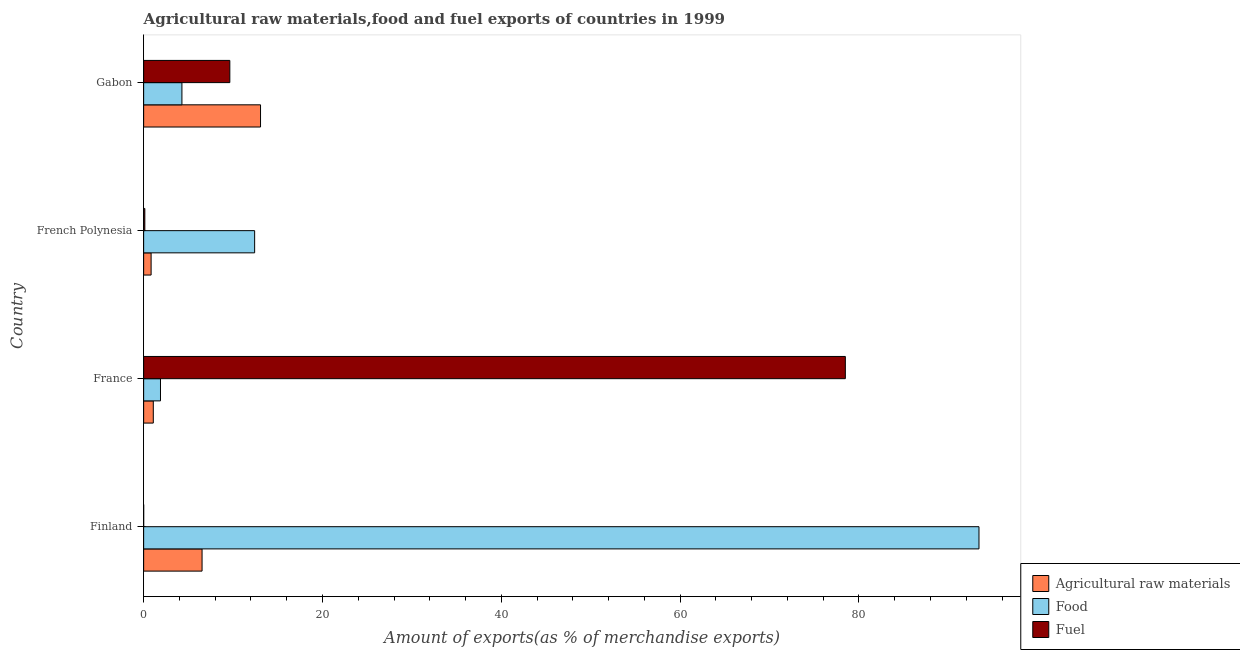How many groups of bars are there?
Offer a very short reply. 4. Are the number of bars on each tick of the Y-axis equal?
Keep it short and to the point. Yes. How many bars are there on the 1st tick from the bottom?
Your response must be concise. 3. What is the label of the 1st group of bars from the top?
Your response must be concise. Gabon. What is the percentage of fuel exports in French Polynesia?
Your answer should be very brief. 0.13. Across all countries, what is the maximum percentage of raw materials exports?
Make the answer very short. 13.07. Across all countries, what is the minimum percentage of raw materials exports?
Ensure brevity in your answer.  0.83. What is the total percentage of food exports in the graph?
Your answer should be very brief. 112. What is the difference between the percentage of raw materials exports in Finland and that in French Polynesia?
Give a very brief answer. 5.7. What is the difference between the percentage of raw materials exports in Finland and the percentage of food exports in Gabon?
Provide a short and direct response. 2.25. What is the average percentage of fuel exports per country?
Your response must be concise. 22.06. What is the difference between the percentage of raw materials exports and percentage of food exports in Finland?
Your answer should be compact. -86.89. What is the ratio of the percentage of raw materials exports in Finland to that in French Polynesia?
Provide a short and direct response. 7.83. What is the difference between the highest and the second highest percentage of raw materials exports?
Give a very brief answer. 6.54. What is the difference between the highest and the lowest percentage of fuel exports?
Provide a short and direct response. 78.47. In how many countries, is the percentage of fuel exports greater than the average percentage of fuel exports taken over all countries?
Ensure brevity in your answer.  1. Is the sum of the percentage of raw materials exports in France and Gabon greater than the maximum percentage of fuel exports across all countries?
Your answer should be very brief. No. What does the 3rd bar from the top in France represents?
Offer a very short reply. Agricultural raw materials. What does the 1st bar from the bottom in Finland represents?
Give a very brief answer. Agricultural raw materials. Is it the case that in every country, the sum of the percentage of raw materials exports and percentage of food exports is greater than the percentage of fuel exports?
Make the answer very short. No. How many bars are there?
Ensure brevity in your answer.  12. What is the difference between two consecutive major ticks on the X-axis?
Your response must be concise. 20. Does the graph contain grids?
Offer a terse response. No. Where does the legend appear in the graph?
Offer a very short reply. Bottom right. How are the legend labels stacked?
Provide a short and direct response. Vertical. What is the title of the graph?
Keep it short and to the point. Agricultural raw materials,food and fuel exports of countries in 1999. What is the label or title of the X-axis?
Keep it short and to the point. Amount of exports(as % of merchandise exports). What is the Amount of exports(as % of merchandise exports) in Agricultural raw materials in Finland?
Keep it short and to the point. 6.53. What is the Amount of exports(as % of merchandise exports) of Food in Finland?
Your response must be concise. 93.42. What is the Amount of exports(as % of merchandise exports) of Fuel in Finland?
Your answer should be very brief. 0. What is the Amount of exports(as % of merchandise exports) of Agricultural raw materials in France?
Your answer should be very brief. 1.08. What is the Amount of exports(as % of merchandise exports) in Food in France?
Make the answer very short. 1.88. What is the Amount of exports(as % of merchandise exports) of Fuel in France?
Your answer should be compact. 78.47. What is the Amount of exports(as % of merchandise exports) in Agricultural raw materials in French Polynesia?
Provide a succinct answer. 0.83. What is the Amount of exports(as % of merchandise exports) in Food in French Polynesia?
Your answer should be very brief. 12.41. What is the Amount of exports(as % of merchandise exports) in Fuel in French Polynesia?
Your response must be concise. 0.13. What is the Amount of exports(as % of merchandise exports) in Agricultural raw materials in Gabon?
Your answer should be very brief. 13.07. What is the Amount of exports(as % of merchandise exports) of Food in Gabon?
Keep it short and to the point. 4.28. What is the Amount of exports(as % of merchandise exports) in Fuel in Gabon?
Give a very brief answer. 9.64. Across all countries, what is the maximum Amount of exports(as % of merchandise exports) in Agricultural raw materials?
Ensure brevity in your answer.  13.07. Across all countries, what is the maximum Amount of exports(as % of merchandise exports) of Food?
Make the answer very short. 93.42. Across all countries, what is the maximum Amount of exports(as % of merchandise exports) of Fuel?
Your answer should be very brief. 78.47. Across all countries, what is the minimum Amount of exports(as % of merchandise exports) in Agricultural raw materials?
Your answer should be compact. 0.83. Across all countries, what is the minimum Amount of exports(as % of merchandise exports) in Food?
Your answer should be compact. 1.88. Across all countries, what is the minimum Amount of exports(as % of merchandise exports) in Fuel?
Give a very brief answer. 0. What is the total Amount of exports(as % of merchandise exports) in Agricultural raw materials in the graph?
Offer a very short reply. 21.52. What is the total Amount of exports(as % of merchandise exports) of Food in the graph?
Provide a short and direct response. 112. What is the total Amount of exports(as % of merchandise exports) in Fuel in the graph?
Ensure brevity in your answer.  88.25. What is the difference between the Amount of exports(as % of merchandise exports) of Agricultural raw materials in Finland and that in France?
Your answer should be compact. 5.45. What is the difference between the Amount of exports(as % of merchandise exports) in Food in Finland and that in France?
Make the answer very short. 91.54. What is the difference between the Amount of exports(as % of merchandise exports) of Fuel in Finland and that in France?
Ensure brevity in your answer.  -78.47. What is the difference between the Amount of exports(as % of merchandise exports) in Agricultural raw materials in Finland and that in French Polynesia?
Make the answer very short. 5.7. What is the difference between the Amount of exports(as % of merchandise exports) in Food in Finland and that in French Polynesia?
Your answer should be compact. 81.01. What is the difference between the Amount of exports(as % of merchandise exports) in Fuel in Finland and that in French Polynesia?
Provide a short and direct response. -0.13. What is the difference between the Amount of exports(as % of merchandise exports) of Agricultural raw materials in Finland and that in Gabon?
Your answer should be very brief. -6.54. What is the difference between the Amount of exports(as % of merchandise exports) in Food in Finland and that in Gabon?
Make the answer very short. 89.14. What is the difference between the Amount of exports(as % of merchandise exports) of Fuel in Finland and that in Gabon?
Offer a very short reply. -9.64. What is the difference between the Amount of exports(as % of merchandise exports) of Agricultural raw materials in France and that in French Polynesia?
Keep it short and to the point. 0.24. What is the difference between the Amount of exports(as % of merchandise exports) in Food in France and that in French Polynesia?
Your response must be concise. -10.53. What is the difference between the Amount of exports(as % of merchandise exports) in Fuel in France and that in French Polynesia?
Ensure brevity in your answer.  78.34. What is the difference between the Amount of exports(as % of merchandise exports) of Agricultural raw materials in France and that in Gabon?
Provide a short and direct response. -11.99. What is the difference between the Amount of exports(as % of merchandise exports) of Food in France and that in Gabon?
Offer a very short reply. -2.4. What is the difference between the Amount of exports(as % of merchandise exports) in Fuel in France and that in Gabon?
Keep it short and to the point. 68.84. What is the difference between the Amount of exports(as % of merchandise exports) of Agricultural raw materials in French Polynesia and that in Gabon?
Your response must be concise. -12.24. What is the difference between the Amount of exports(as % of merchandise exports) of Food in French Polynesia and that in Gabon?
Your answer should be compact. 8.13. What is the difference between the Amount of exports(as % of merchandise exports) in Fuel in French Polynesia and that in Gabon?
Ensure brevity in your answer.  -9.5. What is the difference between the Amount of exports(as % of merchandise exports) in Agricultural raw materials in Finland and the Amount of exports(as % of merchandise exports) in Food in France?
Your answer should be compact. 4.65. What is the difference between the Amount of exports(as % of merchandise exports) of Agricultural raw materials in Finland and the Amount of exports(as % of merchandise exports) of Fuel in France?
Offer a very short reply. -71.94. What is the difference between the Amount of exports(as % of merchandise exports) of Food in Finland and the Amount of exports(as % of merchandise exports) of Fuel in France?
Your answer should be compact. 14.95. What is the difference between the Amount of exports(as % of merchandise exports) of Agricultural raw materials in Finland and the Amount of exports(as % of merchandise exports) of Food in French Polynesia?
Ensure brevity in your answer.  -5.88. What is the difference between the Amount of exports(as % of merchandise exports) of Agricultural raw materials in Finland and the Amount of exports(as % of merchandise exports) of Fuel in French Polynesia?
Make the answer very short. 6.4. What is the difference between the Amount of exports(as % of merchandise exports) of Food in Finland and the Amount of exports(as % of merchandise exports) of Fuel in French Polynesia?
Make the answer very short. 93.29. What is the difference between the Amount of exports(as % of merchandise exports) in Agricultural raw materials in Finland and the Amount of exports(as % of merchandise exports) in Food in Gabon?
Ensure brevity in your answer.  2.25. What is the difference between the Amount of exports(as % of merchandise exports) in Agricultural raw materials in Finland and the Amount of exports(as % of merchandise exports) in Fuel in Gabon?
Ensure brevity in your answer.  -3.1. What is the difference between the Amount of exports(as % of merchandise exports) of Food in Finland and the Amount of exports(as % of merchandise exports) of Fuel in Gabon?
Give a very brief answer. 83.78. What is the difference between the Amount of exports(as % of merchandise exports) in Agricultural raw materials in France and the Amount of exports(as % of merchandise exports) in Food in French Polynesia?
Offer a very short reply. -11.33. What is the difference between the Amount of exports(as % of merchandise exports) of Agricultural raw materials in France and the Amount of exports(as % of merchandise exports) of Fuel in French Polynesia?
Your answer should be compact. 0.95. What is the difference between the Amount of exports(as % of merchandise exports) of Food in France and the Amount of exports(as % of merchandise exports) of Fuel in French Polynesia?
Keep it short and to the point. 1.75. What is the difference between the Amount of exports(as % of merchandise exports) in Agricultural raw materials in France and the Amount of exports(as % of merchandise exports) in Food in Gabon?
Offer a very short reply. -3.2. What is the difference between the Amount of exports(as % of merchandise exports) in Agricultural raw materials in France and the Amount of exports(as % of merchandise exports) in Fuel in Gabon?
Make the answer very short. -8.56. What is the difference between the Amount of exports(as % of merchandise exports) of Food in France and the Amount of exports(as % of merchandise exports) of Fuel in Gabon?
Give a very brief answer. -7.76. What is the difference between the Amount of exports(as % of merchandise exports) of Agricultural raw materials in French Polynesia and the Amount of exports(as % of merchandise exports) of Food in Gabon?
Give a very brief answer. -3.45. What is the difference between the Amount of exports(as % of merchandise exports) in Agricultural raw materials in French Polynesia and the Amount of exports(as % of merchandise exports) in Fuel in Gabon?
Give a very brief answer. -8.8. What is the difference between the Amount of exports(as % of merchandise exports) of Food in French Polynesia and the Amount of exports(as % of merchandise exports) of Fuel in Gabon?
Ensure brevity in your answer.  2.77. What is the average Amount of exports(as % of merchandise exports) in Agricultural raw materials per country?
Offer a terse response. 5.38. What is the average Amount of exports(as % of merchandise exports) in Food per country?
Your answer should be very brief. 28. What is the average Amount of exports(as % of merchandise exports) in Fuel per country?
Provide a short and direct response. 22.06. What is the difference between the Amount of exports(as % of merchandise exports) of Agricultural raw materials and Amount of exports(as % of merchandise exports) of Food in Finland?
Your answer should be compact. -86.89. What is the difference between the Amount of exports(as % of merchandise exports) in Agricultural raw materials and Amount of exports(as % of merchandise exports) in Fuel in Finland?
Make the answer very short. 6.53. What is the difference between the Amount of exports(as % of merchandise exports) of Food and Amount of exports(as % of merchandise exports) of Fuel in Finland?
Keep it short and to the point. 93.42. What is the difference between the Amount of exports(as % of merchandise exports) in Agricultural raw materials and Amount of exports(as % of merchandise exports) in Food in France?
Offer a terse response. -0.8. What is the difference between the Amount of exports(as % of merchandise exports) in Agricultural raw materials and Amount of exports(as % of merchandise exports) in Fuel in France?
Provide a succinct answer. -77.4. What is the difference between the Amount of exports(as % of merchandise exports) in Food and Amount of exports(as % of merchandise exports) in Fuel in France?
Offer a terse response. -76.59. What is the difference between the Amount of exports(as % of merchandise exports) in Agricultural raw materials and Amount of exports(as % of merchandise exports) in Food in French Polynesia?
Keep it short and to the point. -11.58. What is the difference between the Amount of exports(as % of merchandise exports) in Agricultural raw materials and Amount of exports(as % of merchandise exports) in Fuel in French Polynesia?
Provide a succinct answer. 0.7. What is the difference between the Amount of exports(as % of merchandise exports) in Food and Amount of exports(as % of merchandise exports) in Fuel in French Polynesia?
Your answer should be very brief. 12.28. What is the difference between the Amount of exports(as % of merchandise exports) in Agricultural raw materials and Amount of exports(as % of merchandise exports) in Food in Gabon?
Make the answer very short. 8.79. What is the difference between the Amount of exports(as % of merchandise exports) in Agricultural raw materials and Amount of exports(as % of merchandise exports) in Fuel in Gabon?
Offer a terse response. 3.43. What is the difference between the Amount of exports(as % of merchandise exports) of Food and Amount of exports(as % of merchandise exports) of Fuel in Gabon?
Give a very brief answer. -5.36. What is the ratio of the Amount of exports(as % of merchandise exports) in Agricultural raw materials in Finland to that in France?
Your response must be concise. 6.05. What is the ratio of the Amount of exports(as % of merchandise exports) in Food in Finland to that in France?
Offer a terse response. 49.64. What is the ratio of the Amount of exports(as % of merchandise exports) in Agricultural raw materials in Finland to that in French Polynesia?
Offer a very short reply. 7.83. What is the ratio of the Amount of exports(as % of merchandise exports) of Food in Finland to that in French Polynesia?
Keep it short and to the point. 7.53. What is the ratio of the Amount of exports(as % of merchandise exports) of Fuel in Finland to that in French Polynesia?
Offer a very short reply. 0.01. What is the ratio of the Amount of exports(as % of merchandise exports) of Agricultural raw materials in Finland to that in Gabon?
Provide a succinct answer. 0.5. What is the ratio of the Amount of exports(as % of merchandise exports) in Food in Finland to that in Gabon?
Give a very brief answer. 21.82. What is the ratio of the Amount of exports(as % of merchandise exports) of Fuel in Finland to that in Gabon?
Make the answer very short. 0. What is the ratio of the Amount of exports(as % of merchandise exports) in Agricultural raw materials in France to that in French Polynesia?
Your response must be concise. 1.29. What is the ratio of the Amount of exports(as % of merchandise exports) in Food in France to that in French Polynesia?
Provide a short and direct response. 0.15. What is the ratio of the Amount of exports(as % of merchandise exports) in Fuel in France to that in French Polynesia?
Your answer should be very brief. 591.08. What is the ratio of the Amount of exports(as % of merchandise exports) in Agricultural raw materials in France to that in Gabon?
Your response must be concise. 0.08. What is the ratio of the Amount of exports(as % of merchandise exports) of Food in France to that in Gabon?
Your answer should be compact. 0.44. What is the ratio of the Amount of exports(as % of merchandise exports) of Fuel in France to that in Gabon?
Provide a succinct answer. 8.14. What is the ratio of the Amount of exports(as % of merchandise exports) of Agricultural raw materials in French Polynesia to that in Gabon?
Provide a short and direct response. 0.06. What is the ratio of the Amount of exports(as % of merchandise exports) in Food in French Polynesia to that in Gabon?
Keep it short and to the point. 2.9. What is the ratio of the Amount of exports(as % of merchandise exports) in Fuel in French Polynesia to that in Gabon?
Offer a terse response. 0.01. What is the difference between the highest and the second highest Amount of exports(as % of merchandise exports) of Agricultural raw materials?
Keep it short and to the point. 6.54. What is the difference between the highest and the second highest Amount of exports(as % of merchandise exports) of Food?
Your answer should be very brief. 81.01. What is the difference between the highest and the second highest Amount of exports(as % of merchandise exports) of Fuel?
Provide a short and direct response. 68.84. What is the difference between the highest and the lowest Amount of exports(as % of merchandise exports) of Agricultural raw materials?
Ensure brevity in your answer.  12.24. What is the difference between the highest and the lowest Amount of exports(as % of merchandise exports) in Food?
Provide a succinct answer. 91.54. What is the difference between the highest and the lowest Amount of exports(as % of merchandise exports) in Fuel?
Your answer should be compact. 78.47. 